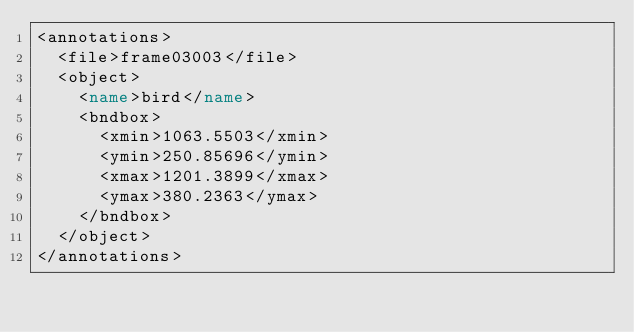<code> <loc_0><loc_0><loc_500><loc_500><_XML_><annotations>
  <file>frame03003</file>
  <object>
    <name>bird</name>
    <bndbox>
      <xmin>1063.5503</xmin>
      <ymin>250.85696</ymin>
      <xmax>1201.3899</xmax>
      <ymax>380.2363</ymax>
    </bndbox>
  </object>
</annotations>
</code> 